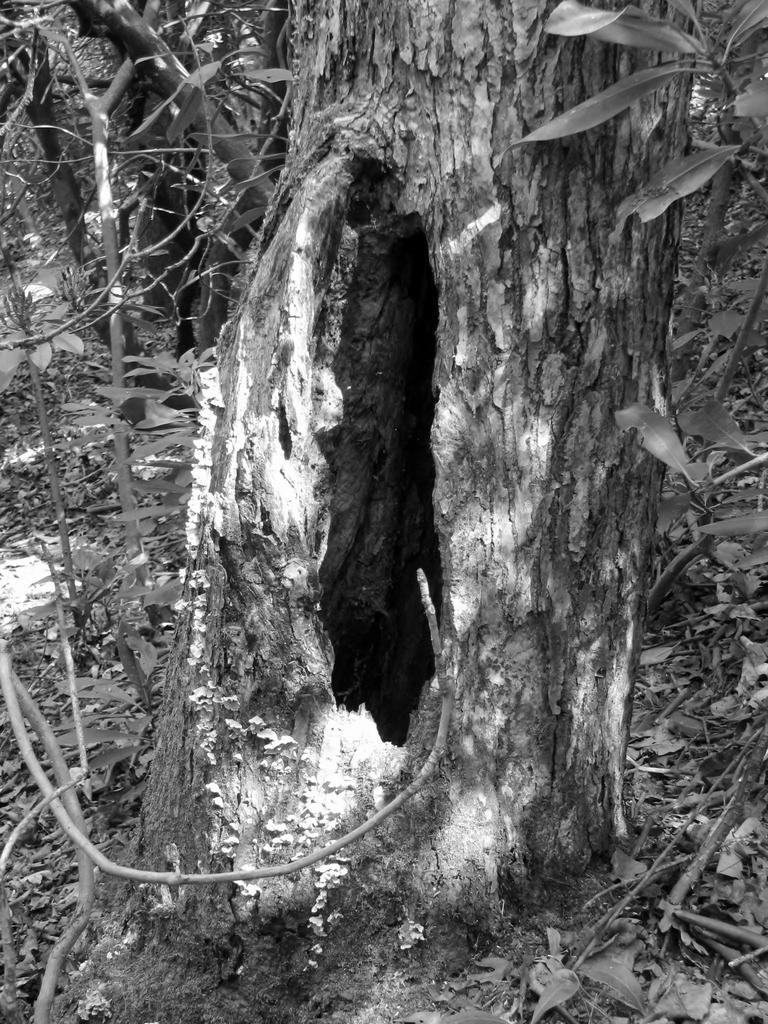How would you summarize this image in a sentence or two? It is a black and white image. Here we can see a hole on a tree trunk. On the left side and right side, we can see few plants. 